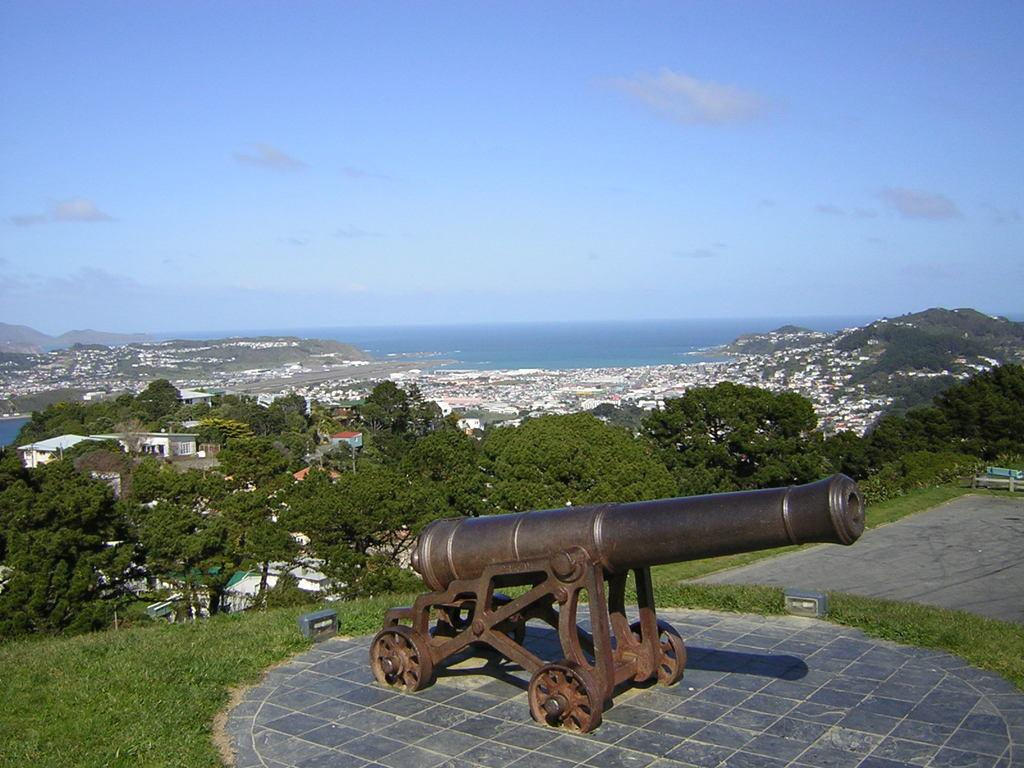What is the main object in the image? There is a cannon in the image. What can be seen in the foreground of the image? There is a path and green grass in the image. What is visible in the background of the image? There are trees, buildings, water, and the sky visible in the background of the image. What type of terrain is present in the image? There is a hill in the image. What type of appliance can be seen on the hill in the image? There are no appliances present in the image. How many snails can be seen crawling on the path in the image? There are no snails visible in the image. 